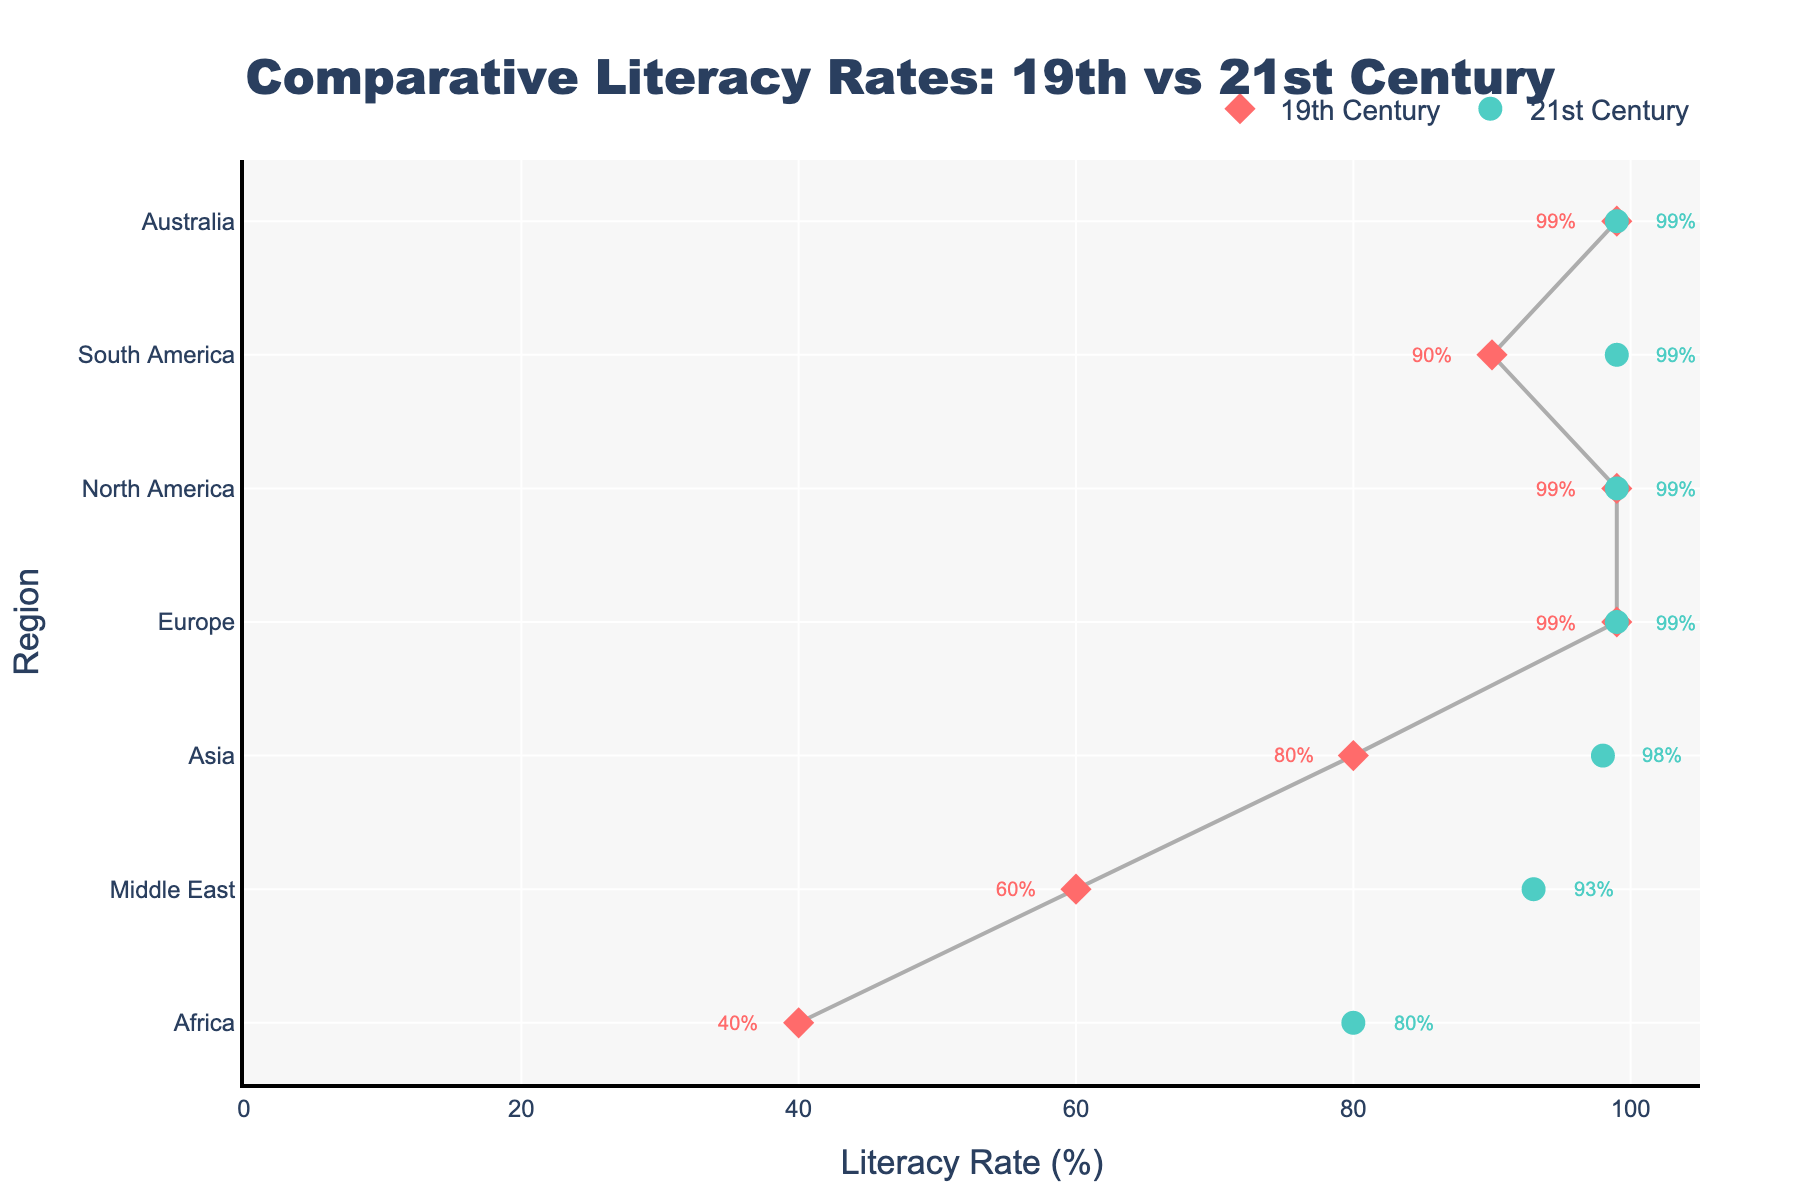What's the title of the figure? The title is at the top of the figure, indicating the purpose and scope of the visual data. It reads "Comparative Literacy Rates: 19th vs 21st Century"
Answer: Comparative Literacy Rates: 19th vs 21st Century Which region had the highest literacy rate in the 19th century? By examining the red diamond markers on the dumbbell plot, which represent 19th-century literacy rates, we find North America at 75%.
Answer: North America What is the literacy rate difference for Africa between the 19th and 21st centuries? Africa's literacy rate in the 19th century is marked by a red diamond at 2%, and in the 21st century by a green circle at 80%. The difference is 80% - 2% = 78%.
Answer: 78% How many regions have reached a literacy rate of 99% by the 21st century? Looking at the green circle markers in the dumbbell plot, the regions with a literacy rate of 99% in the 21st century are Europe, North America, South America, and Australia. This accounts for 4 regions.
Answer: 4 Which region showed the most significant improvement in literacy rate from the 19th to the 21st century? By assessing the differences between the red diamond and green circle markers for each region, Africa shows the largest increase from 2% to 80%, a 78% rise.
Answer: Africa What is the average literacy rate in the 19th century for all regions? Adding all the 19th-century literacy rates: 25% (Europe) + 10% (Asia) + 2% (Africa) + 75% (North America) + 15% (South America) + 45% (Australia) + 3% (Middle East) = 175%, divided by 7 regions gives 175% / 7 = 25%.
Answer: 25% Which two regions had equal literacy rates in the 21st century? Observing the green circles, Europe and North America both had a literacy rate of 99% in the 21st century.
Answer: Europe and North America What is the literacy rate gain for the Middle East from the 19th to the 21st century? The Middle East had a literacy rate of 3% in the 19th century and 93% in the 21st century. The gain is 93% - 3% = 90%.
Answer: 90% Compare the literacy rate increase between Asia and South America from the 19th to the 21st century. Asia's literacy rate rose from 10% to 98%, a gain of 88%. South America's rate increased from 15% to 99%, a gain of 84%. Comparing these, Asia's increase (88%) is slightly more than South America's (84%).
Answer: Asia Which region had the smallest improvement in literacy rate from the 19th to the 21st century? Examining the shifts between red diamonds and green circles, North America shows the smallest improvement, as it moved from 75% to 99%, a 24% increase.
Answer: North America 